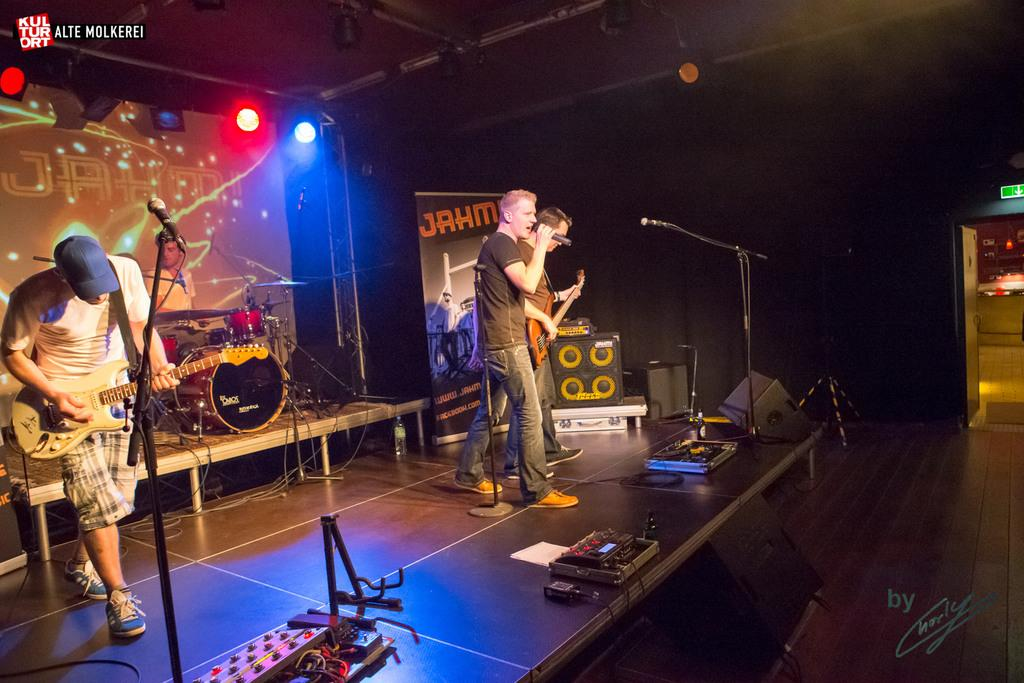How many people are performing in the image? There are four people standing and performing in the image. Where is the performance taking place? The performance is taking place on a stage. What musical instrument can be seen in the image? A guitar is present in the image. What type of group is performing? There is a musical band performing. What can be seen illuminating the stage? Lights are visible in the image. What device might be used to amplify the sound? There is a sound box present in the image. Can you tell me how many yaks are on stage with the band? There are no yaks present in the image; it features a musical band performing on a stage. What type of lift is being used by the band members during the performance? There is no lift visible in the image, and the band members are standing and performing on the stage. 